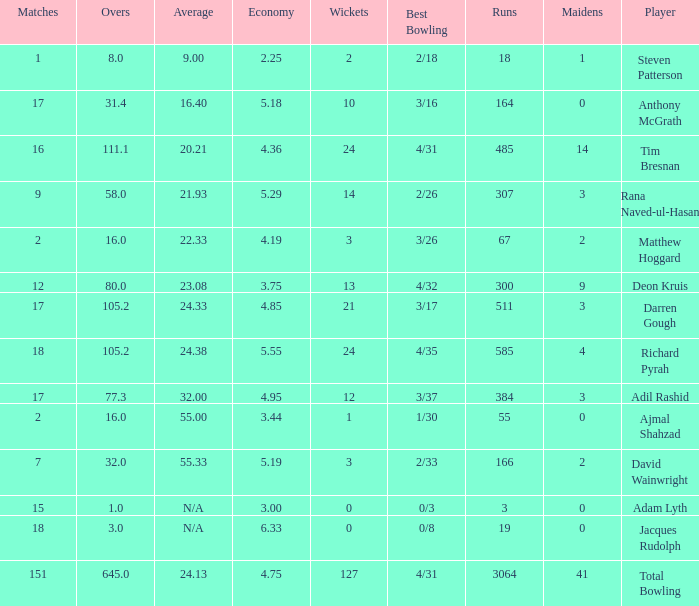What is the lowest Overs with a Run that is 18? 8.0. 